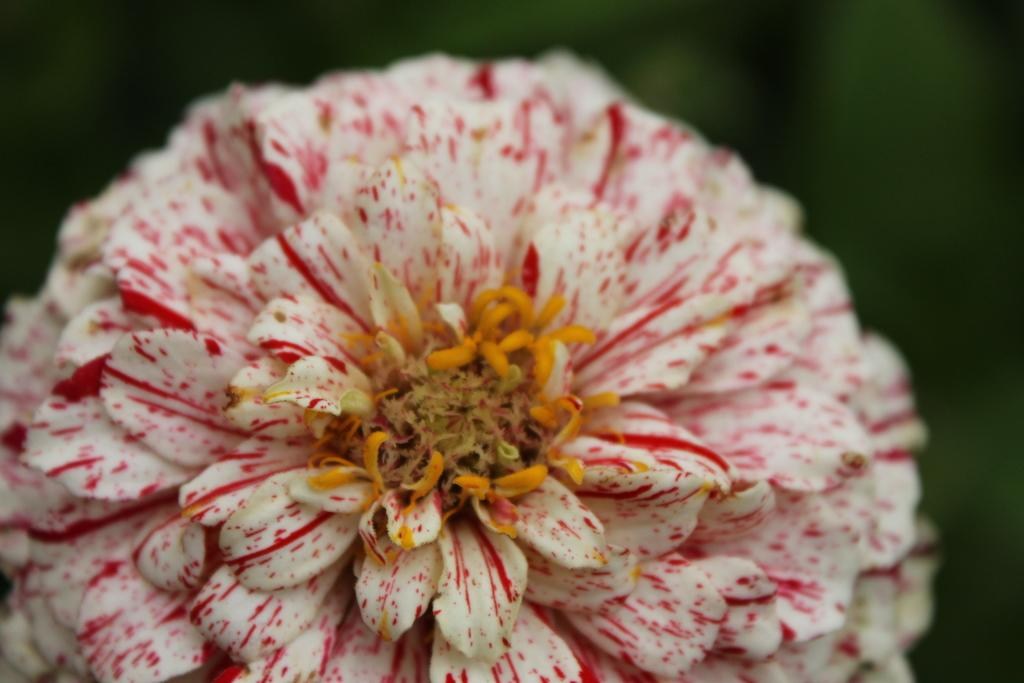What is the main subject of the image? There is a flower in the image. Can you describe the background of the image? The background of the image is blurred. Where is the zebra grazing in the image? There is no zebra present in the image; it only features a flower. What type of breakfast is being served in the image? There is no breakfast or any food items visible in the image. 